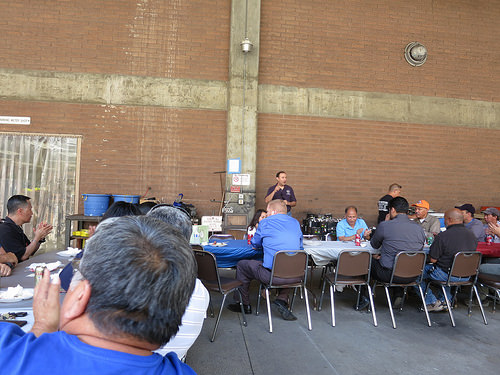<image>
Can you confirm if the youth is behind the male? No. The youth is not behind the male. From this viewpoint, the youth appears to be positioned elsewhere in the scene. 